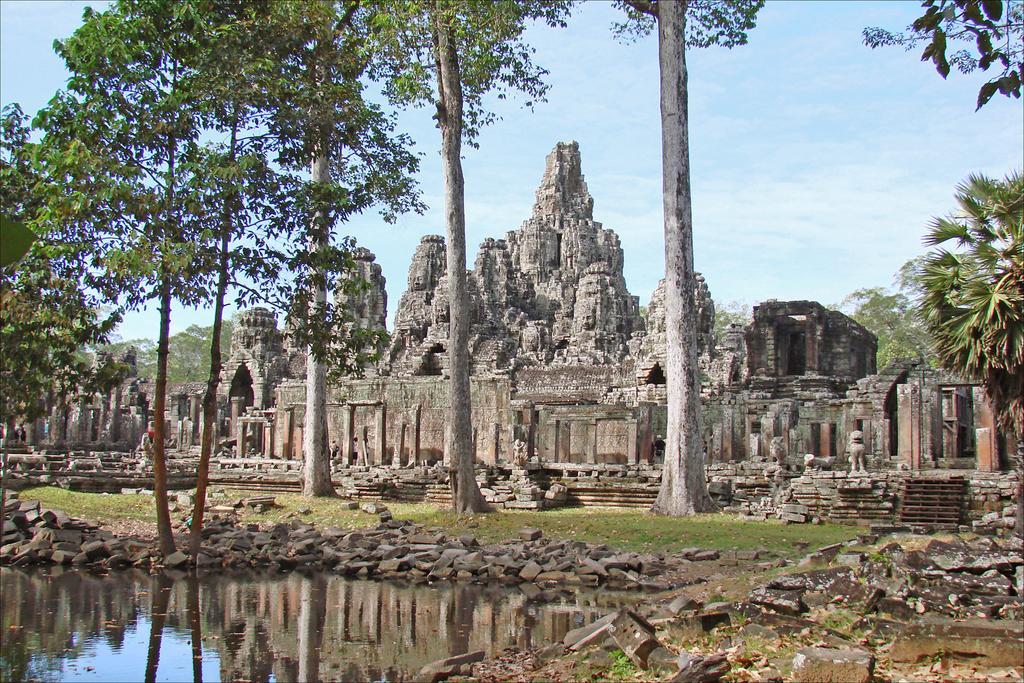In one or two sentences, can you explain what this image depicts? In this image there is a historical site. There are caves, sculptures and pillars. In the foreground there are trees, small rocks and grass on the ground. At the bottom there is the water. In the background there are trees. At the top there is the sky. 